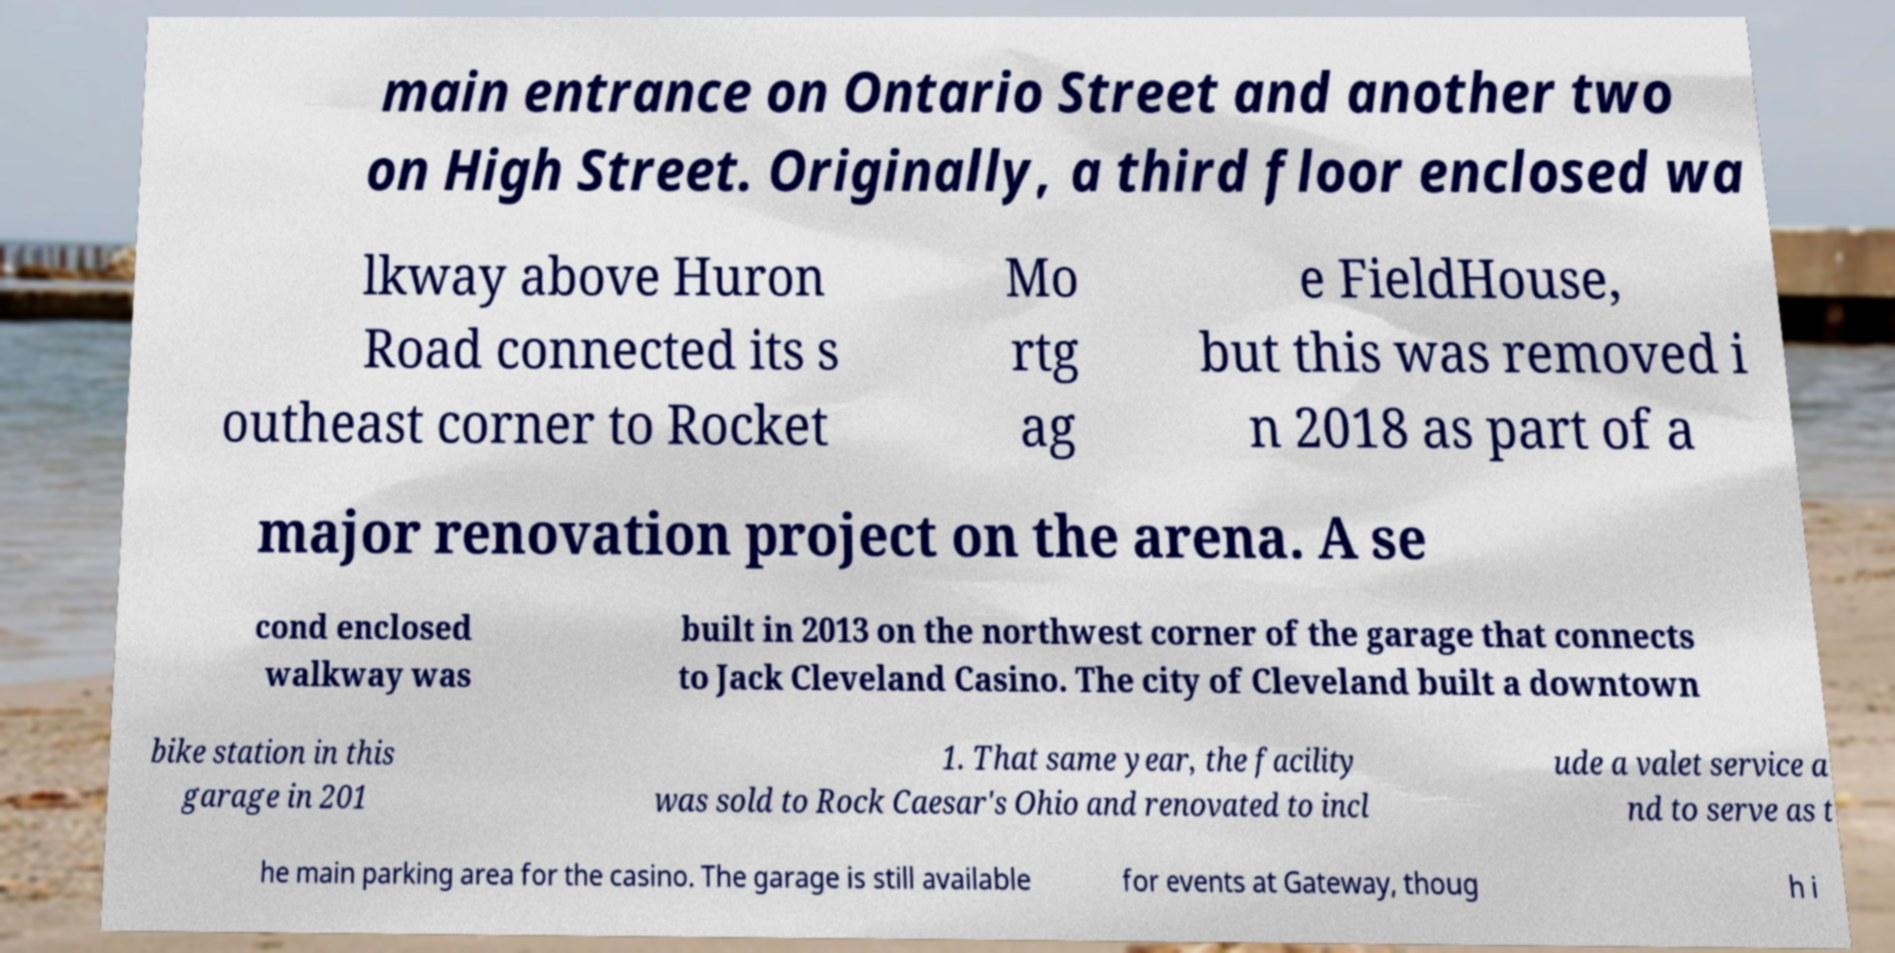For documentation purposes, I need the text within this image transcribed. Could you provide that? main entrance on Ontario Street and another two on High Street. Originally, a third floor enclosed wa lkway above Huron Road connected its s outheast corner to Rocket Mo rtg ag e FieldHouse, but this was removed i n 2018 as part of a major renovation project on the arena. A se cond enclosed walkway was built in 2013 on the northwest corner of the garage that connects to Jack Cleveland Casino. The city of Cleveland built a downtown bike station in this garage in 201 1. That same year, the facility was sold to Rock Caesar's Ohio and renovated to incl ude a valet service a nd to serve as t he main parking area for the casino. The garage is still available for events at Gateway, thoug h i 